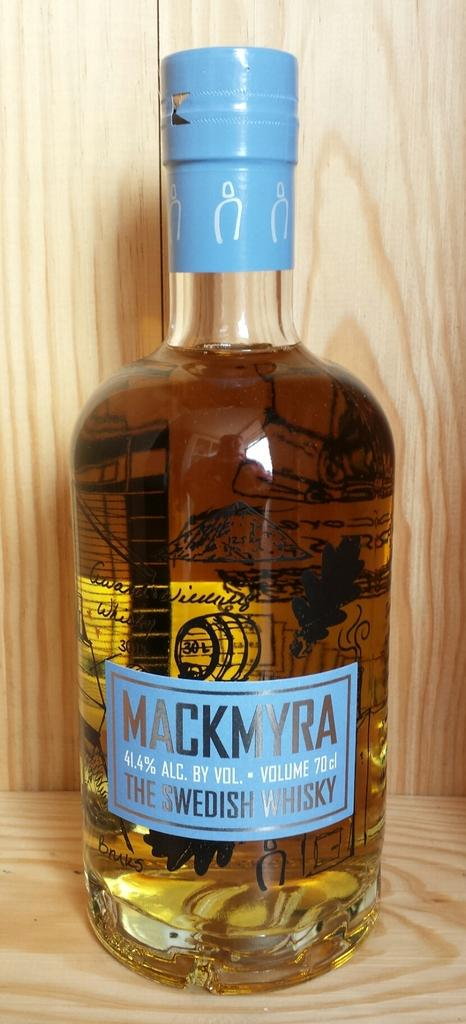<image>
Offer a succinct explanation of the picture presented. a bottle of mackmyra the swedish whiskey with a blue label 